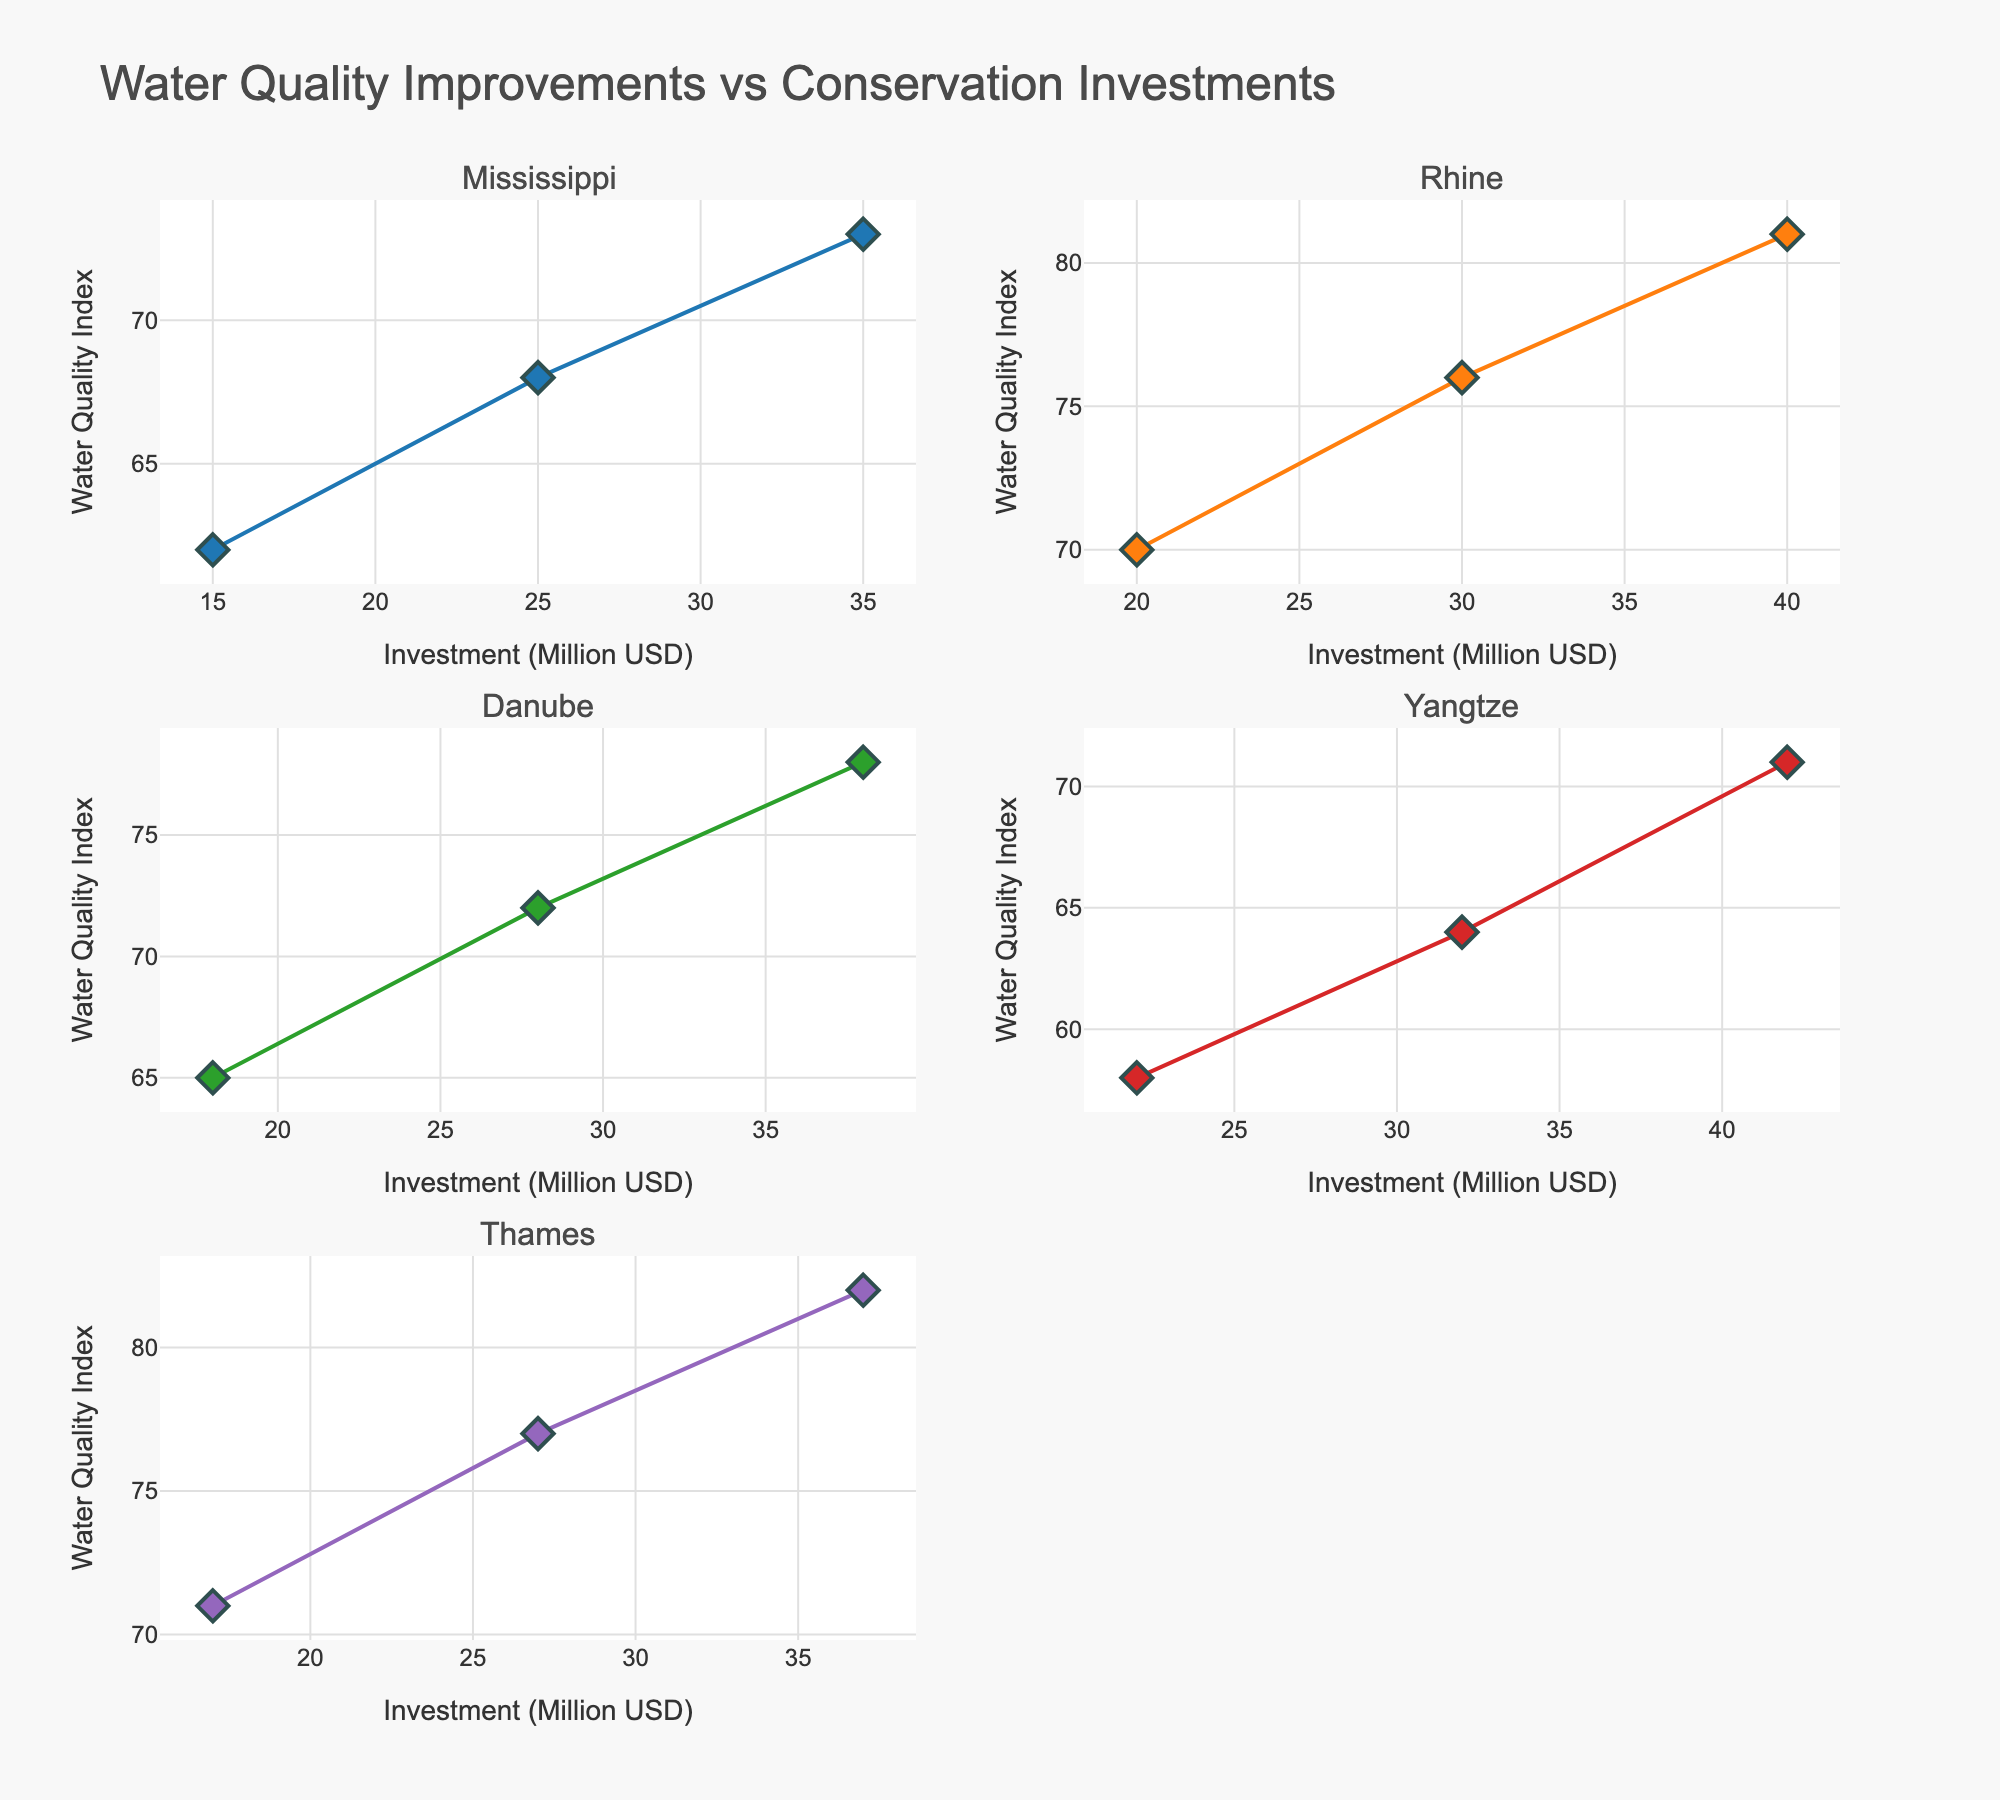What's the title of the figure? The title is located at the top of the image and stands out as the largest text element.
Answer: Distribution of Writing Materials in Ancient Inscriptions What writing material had the highest usage during the period 0-500 CE? Looking at the subplots for each material, the bar corresponding to "Metal" in the 0-500 CE time period has the highest value.
Answer: Metal Which material's usage decreased consistently across all time periods? Observing the bars for each material in sequence, only the bars for "Stone" show a consistent decrease in value from 3000-2000 BCE to 500-1000 CE.
Answer: Stone How many subplots are there in the figure? Visually count the number of small individual plots within the entire figure.
Answer: 5 What material showed the greatest increase in usage between 3000-2000 BCE and 500-1000 CE? Compare the bars for each material between the two time periods, "Papyrus" shows the largest increase going from 5 to 30.
Answer: Papyrus During which time period did "Wood" have the lowest usage? Identify the bar heights for "Wood" in all subplots, they all appear equal at 5, indicating no change in usage.
Answer: Equal across all periods Compare the usage of "Clay" and "Papyrus" in the time period 1000 BCE-0 CE. Which had higher usage? In the subplot for 1000 BCE-0 CE, the bar for "Papyrus" is higher than the bar for "Clay."
Answer: Papyrus Calculate the average usage of "Metal" across all time periods. Add the values for "Metal" in all time periods (15 + 20 + 25 + 30 + 35 = 125) and divide by the number of periods (5), resulting in an average usage.
Answer: 25 What material had the largest usage difference between any two consecutive time periods? Comparing the changes in usage for each material between all consecutive periods:
- Stone: 45-40 = 5, 40-35 = 5, 35-30 = 5, 30-25 = 5
- Clay: 30-35 = -5, 35-25 = 10, 25-20 = 5, 20-15 = 5
- Metal: 15-20 = -5, 20-25 = 5, 25-30 = 5, 30-35 = 5
- Papyrus: 5-10 = -5, 10-20 = -10, 20-25 = 5, 25-30 = -5
"Papyrus" has the largest difference of 10 going from 10 to 20.
Answer: Clay What percentage of the total materials usage in the time period 2000-1000 BCE does "Stone" account for? Calculate the total usage for all materials (40 + 35 + 20 + 10 + 5 = 110). The percentage for "Stone" is (40/110) * 100%.
Answer: 36.36% 